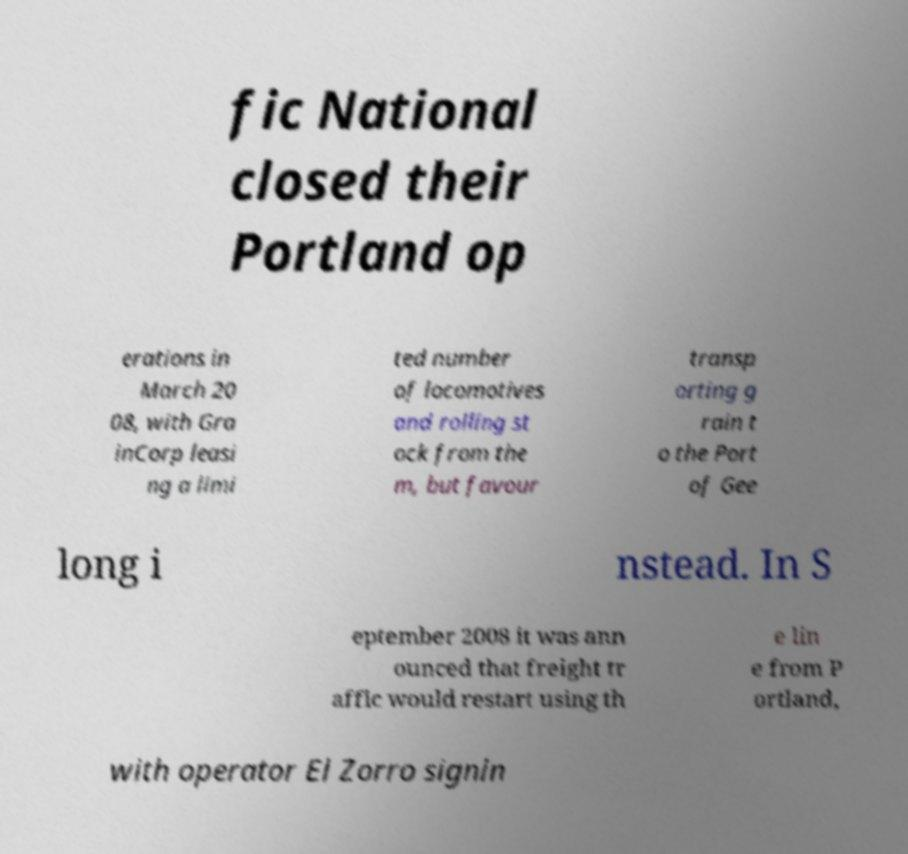Can you read and provide the text displayed in the image?This photo seems to have some interesting text. Can you extract and type it out for me? fic National closed their Portland op erations in March 20 08, with Gra inCorp leasi ng a limi ted number of locomotives and rolling st ock from the m, but favour transp orting g rain t o the Port of Gee long i nstead. In S eptember 2008 it was ann ounced that freight tr affic would restart using th e lin e from P ortland, with operator El Zorro signin 